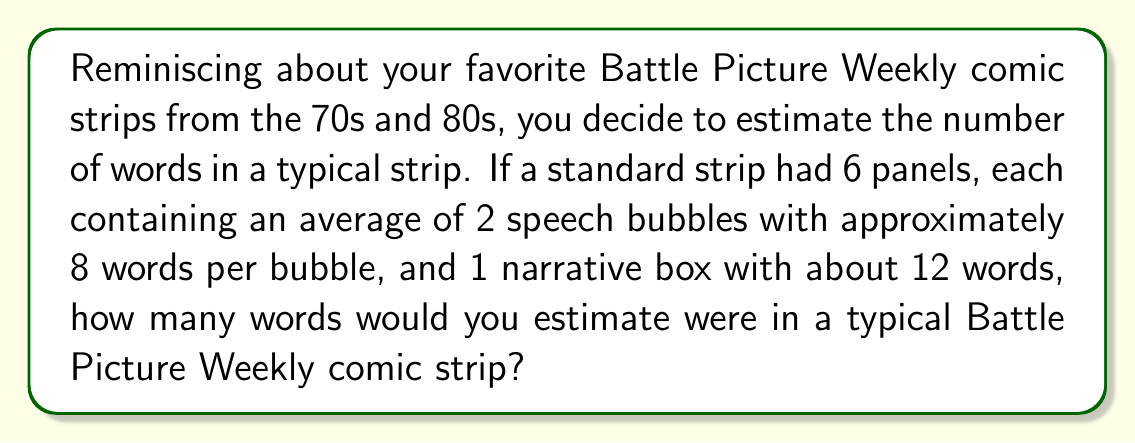Show me your answer to this math problem. Let's break this down step-by-step:

1. First, let's calculate the words in speech bubbles per panel:
   $$ \text{Words in bubbles per panel} = 2 \text{ bubbles} \times 8 \text{ words} = 16 \text{ words} $$

2. Now, add the words in the narrative box:
   $$ \text{Total words per panel} = 16 + 12 = 28 \text{ words} $$

3. Finally, multiply by the number of panels in a typical strip:
   $$ \text{Total words in strip} = 28 \text{ words} \times 6 \text{ panels} = 168 \text{ words} $$

Therefore, we estimate that a typical Battle Picture Weekly comic strip contained approximately 168 words.
Answer: $168$ words 